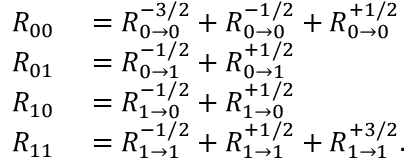Convert formula to latex. <formula><loc_0><loc_0><loc_500><loc_500>\begin{array} { r l } { R _ { 0 0 } } & = R _ { 0 \rightarrow 0 } ^ { - 3 / 2 } + R _ { 0 \rightarrow 0 } ^ { - 1 / 2 } + R _ { 0 \rightarrow 0 } ^ { + 1 / 2 } } \\ { R _ { 0 1 } } & = R _ { 0 \rightarrow 1 } ^ { - 1 / 2 } + R _ { 0 \rightarrow 1 } ^ { + 1 / 2 } } \\ { R _ { 1 0 } } & = R _ { 1 \rightarrow 0 } ^ { - 1 / 2 } + R _ { 1 \rightarrow 0 } ^ { + 1 / 2 } } \\ { R _ { 1 1 } } & = R _ { 1 \rightarrow 1 } ^ { - 1 / 2 } + R _ { 1 \rightarrow 1 } ^ { + 1 / 2 } + R _ { 1 \rightarrow 1 } ^ { + 3 / 2 } . } \end{array}</formula> 